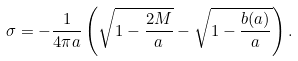<formula> <loc_0><loc_0><loc_500><loc_500>\sigma = - \frac { 1 } { 4 \pi a } \left ( \sqrt { 1 - \frac { 2 M } { a } } - \sqrt { 1 - \frac { b ( a ) } { a } } \right ) .</formula> 